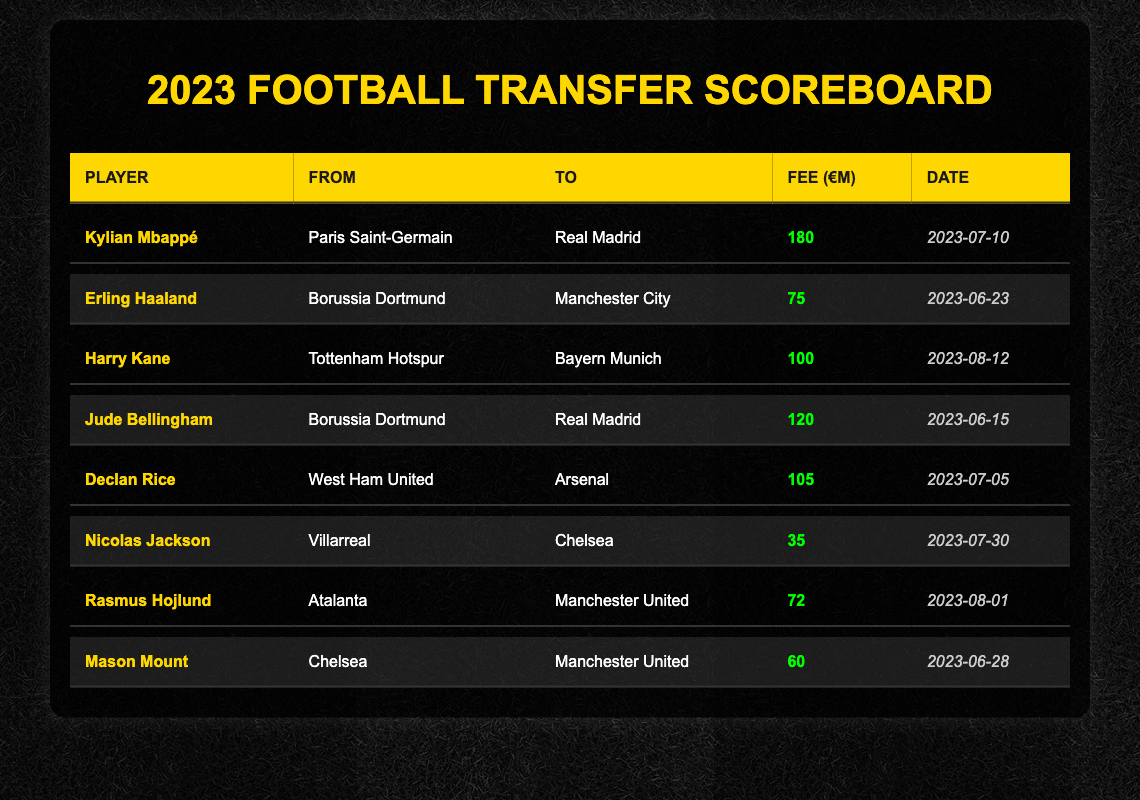What is the highest transfer fee listed in the table? Scanning the 'Fee (€M)' column of the table, I see that the highest value is 180, which belongs to Kylian Mbappé.
Answer: 180 Which player transferred from Borussia Dortmund in 2023? Looking at the 'From' column for Borussia Dortmund, I can identify two players: Erling Haaland and Jude Bellingham.
Answer: Erling Haaland and Jude Bellingham What was the transfer fee for Declan Rice? I can directly locate Declan Rice in the 'Player' column, and the corresponding 'Fee (€M)' column shows the value of 105 million.
Answer: 105 Did any player transfer to Manchester City in August 2023? I will refer to the 'To' column for Manchester City and check the 'Date' column to find any transfers in August 2023. The only relevant player is Erling Haaland, who transferred on June 23, so the answer is no.
Answer: No Calculate the average transfer fee of players who moved to Manchester United. The transfer fees for players moving to Manchester United are 72 (Rasmus Hojlund) and 60 (Mason Mount). To find the average: (72 + 60) / 2 = 66.
Answer: 66 Which club received the highest fee for a player in the data? Comparing the fees received by various clubs, I note that Paris Saint-Germain received 180 million for Kylian Mbappé. No other clubs received a fee that high.
Answer: Paris Saint-Germain Which two players were transferred to Real Madrid in 2023? By checking the 'To' column for Real Madrid, I find Kylian Mbappé and Jude Bellingham, confirming they are the players who made this transfer.
Answer: Kylian Mbappé and Jude Bellingham What is the total transfer fee spent by Arsenal on new players in 2023? The only player listed who transferred to Arsenal is Declan Rice, with a fee of 105 million. Therefore, the total transfer fee spent by Arsenal is 105 million.
Answer: 105 Who transferred to Chelsea for a fee less than 50 million? Filter the 'To' column for Chelsea while checking their fees. I see Nicolas Jackson, whose transfer fee was 35 million, fits this criterion.
Answer: Nicolas Jackson Did Harry Kane's transfer fee exceed that of Erling Haaland? Harry Kane has a transfer fee of 100 million, while Erling Haaland has a fee of 75 million. Since 100 is greater than 75, the answer is yes.
Answer: Yes 